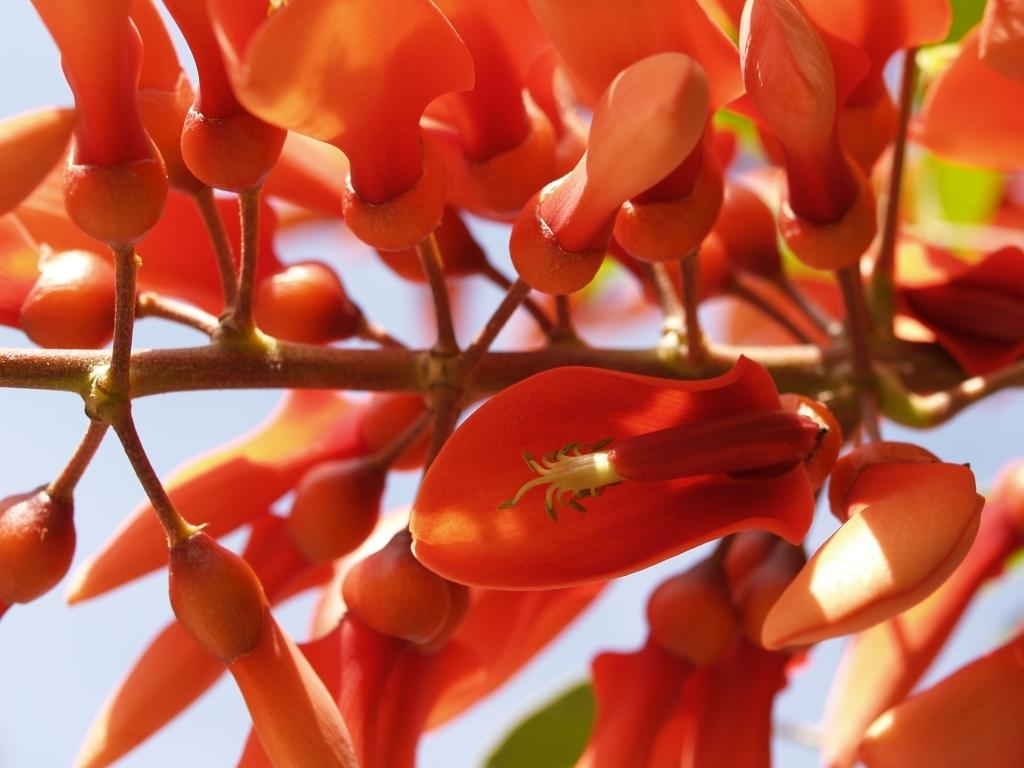What is the main subject of the image? There is a group of flowers in the image. Can you describe any other plant features in the image? There are buds on the branch of a tree in the image. What can be seen in the background of the image? The sky is visible in the background of the image. How does the group of flowers rub against the mountain in the image? There is no mountain present in the image, so the flowers cannot rub against it. 